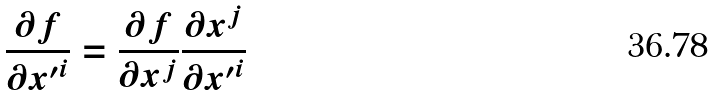<formula> <loc_0><loc_0><loc_500><loc_500>\frac { \partial f } { \partial { x ^ { \prime } } ^ { i } } = \frac { \partial f } { \partial x ^ { j } } \frac { \partial x ^ { j } } { \partial { x ^ { \prime } } ^ { i } }</formula> 